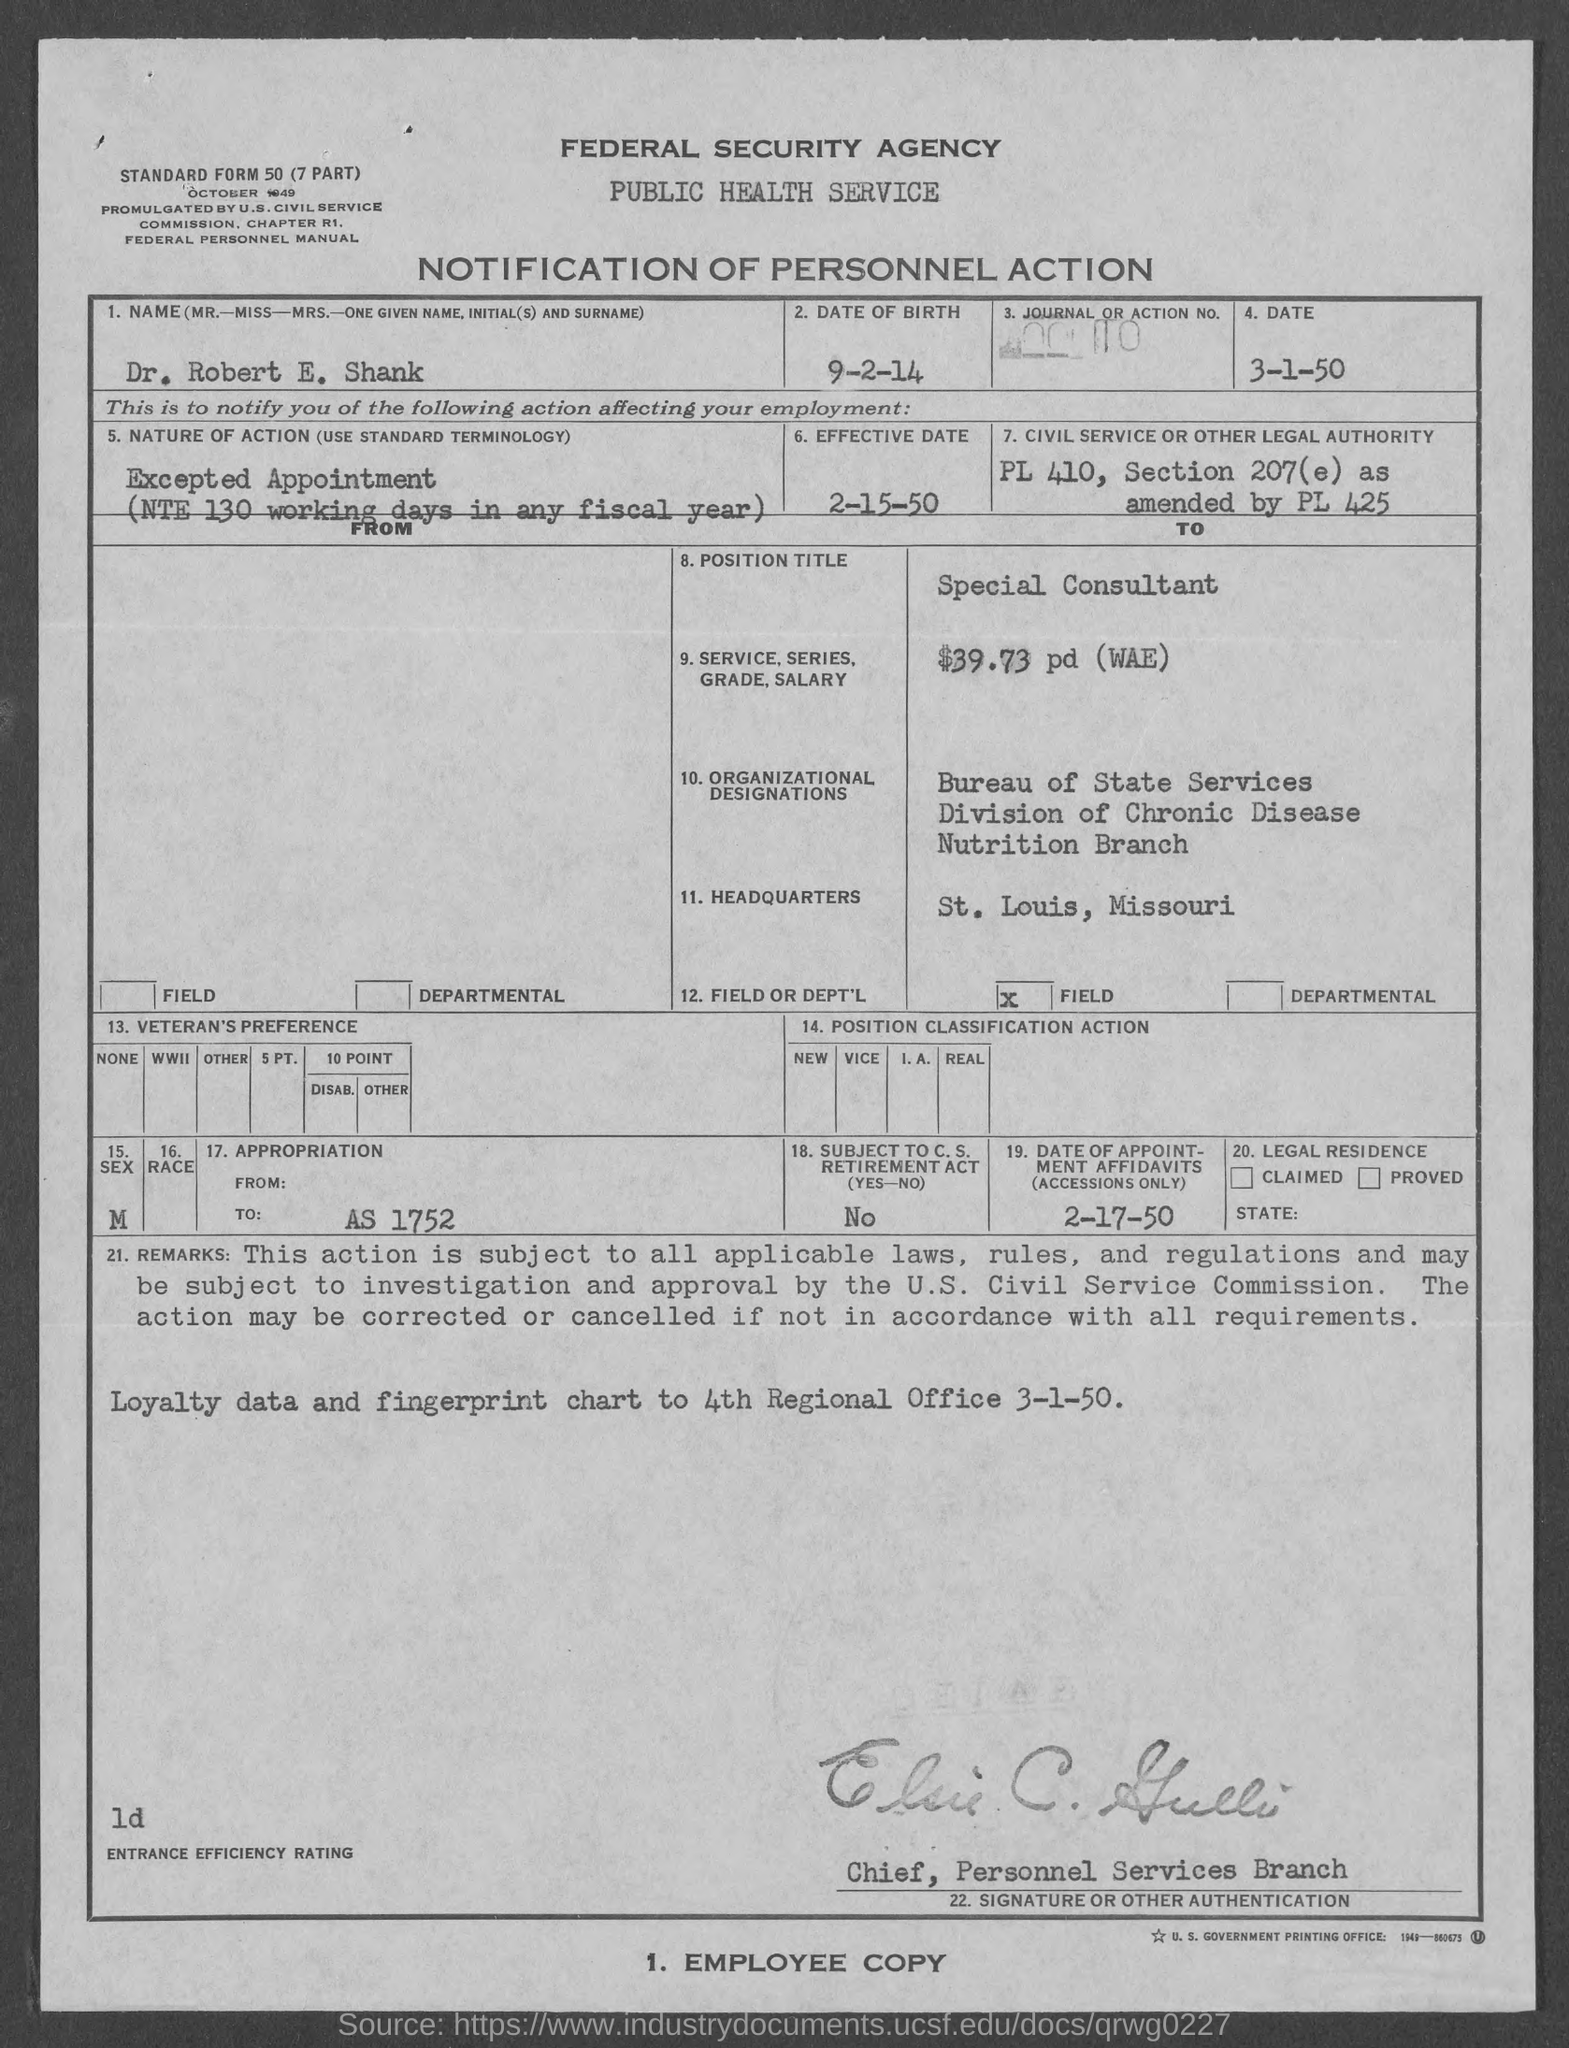What is the Title of the document?
Provide a short and direct response. Notification of Personnel Action. What is the Name?
Your answer should be very brief. Dr. Robert E. Shank. What is the date of birth?
Keep it short and to the point. 9-2-14. What is the Date?
Offer a very short reply. 3-1-50. When is the effective date?
Your response must be concise. 2-15-50. What is the Position Title?
Provide a succinct answer. Special Consultant. What is the service series grade, salary?
Your response must be concise. $39.73 pd (WAE). Where is the Headquarters?
Provide a succinct answer. St. Louis, Missouri. What is the date of appointment affidavits?
Your answer should be very brief. 2-17-50. What is the Appropriation to?
Your answer should be very brief. AS 1752. 